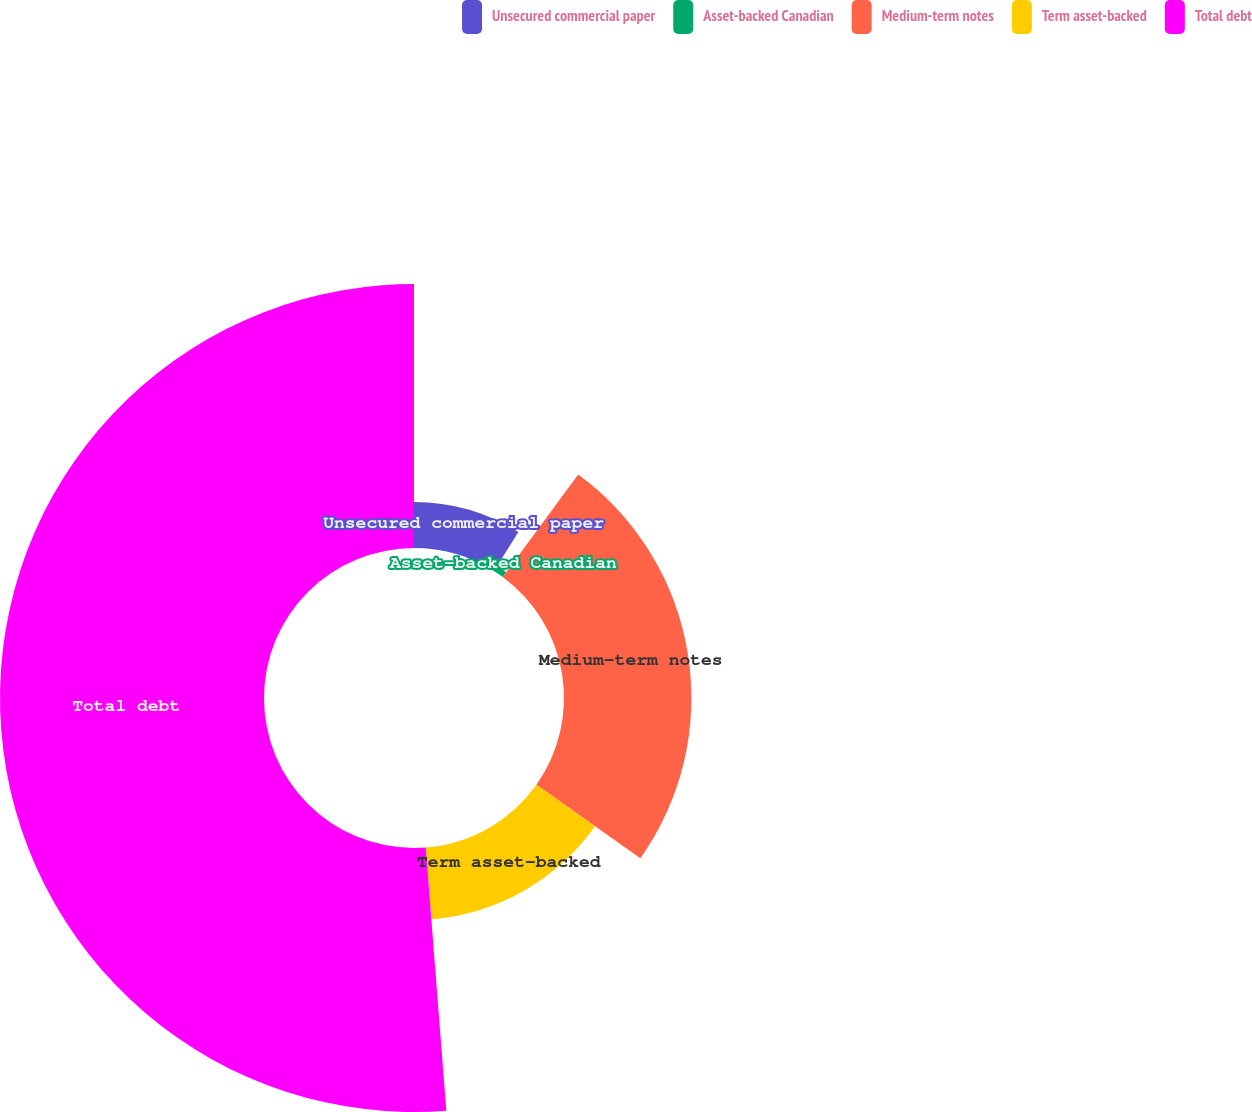Convert chart to OTSL. <chart><loc_0><loc_0><loc_500><loc_500><pie_chart><fcel>Unsecured commercial paper<fcel>Asset-backed Canadian<fcel>Medium-term notes<fcel>Term asset-backed<fcel>Total debt<nl><fcel>8.94%<fcel>1.14%<fcel>24.73%<fcel>13.95%<fcel>51.25%<nl></chart> 